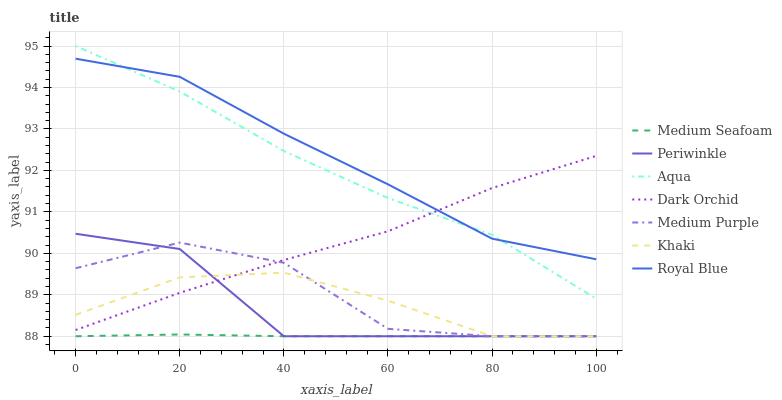Does Medium Seafoam have the minimum area under the curve?
Answer yes or no. Yes. Does Royal Blue have the maximum area under the curve?
Answer yes or no. Yes. Does Aqua have the minimum area under the curve?
Answer yes or no. No. Does Aqua have the maximum area under the curve?
Answer yes or no. No. Is Medium Seafoam the smoothest?
Answer yes or no. Yes. Is Periwinkle the roughest?
Answer yes or no. Yes. Is Aqua the smoothest?
Answer yes or no. No. Is Aqua the roughest?
Answer yes or no. No. Does Khaki have the lowest value?
Answer yes or no. Yes. Does Aqua have the lowest value?
Answer yes or no. No. Does Aqua have the highest value?
Answer yes or no. Yes. Does Dark Orchid have the highest value?
Answer yes or no. No. Is Periwinkle less than Royal Blue?
Answer yes or no. Yes. Is Royal Blue greater than Medium Purple?
Answer yes or no. Yes. Does Dark Orchid intersect Aqua?
Answer yes or no. Yes. Is Dark Orchid less than Aqua?
Answer yes or no. No. Is Dark Orchid greater than Aqua?
Answer yes or no. No. Does Periwinkle intersect Royal Blue?
Answer yes or no. No. 